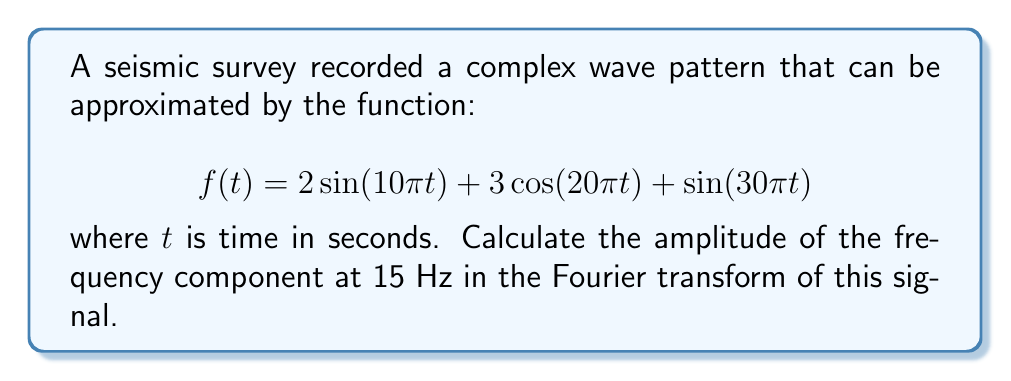Show me your answer to this math problem. To solve this problem, we'll follow these steps:

1) Recall that the Fourier transform of a sinusoidal function is given by:
   
   $$\mathcal{F}\{A\sin(2\pi ft)\} = \frac{iA}{2}[\delta(F-f) - \delta(F+f)]$$
   $$\mathcal{F}\{A\cos(2\pi ft)\} = \frac{A}{2}[\delta(F-f) + \delta(F+f)]$$

   where $f$ is the frequency, $F$ is the frequency variable in the Fourier domain, and $\delta$ is the Dirac delta function.

2) Identify the frequencies in the given function:
   
   - $2\sin(10\pi t)$ has $f_1 = 5$ Hz
   - $3\cos(20\pi t)$ has $f_2 = 10$ Hz
   - $\sin(30\pi t)$ has $f_3 = 15$ Hz

3) Apply the Fourier transform to each term:
   
   $$\mathcal{F}\{2\sin(10\pi t)\} = i[\delta(F-5) - \delta(F+5)]$$
   $$\mathcal{F}\{3\cos(20\pi t)\} = \frac{3}{2}[\delta(F-10) + \delta(F+10)]$$
   $$\mathcal{F}\{\sin(30\pi t)\} = \frac{i}{2}[\delta(F-15) - \delta(F+15)]$$

4) The amplitude of a complex number $a+bi$ is given by $\sqrt{a^2 + b^2}$.

5) For the frequency component at 15 Hz, only the third term contributes:
   
   $$\frac{i}{2}[\delta(F-15) - \delta(F+15)]$$

   The amplitude is thus $\frac{1}{2}$.
Answer: 0.5 